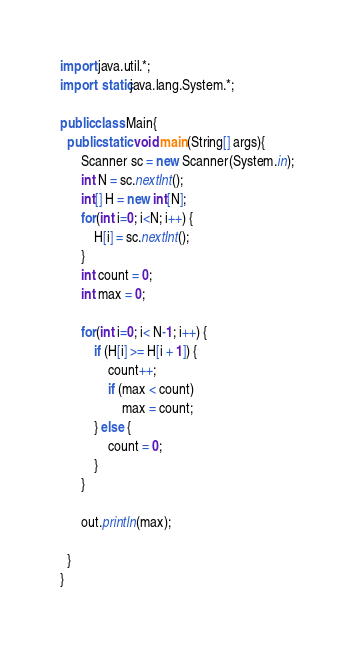Convert code to text. <code><loc_0><loc_0><loc_500><loc_500><_Java_>import java.util.*;
import static java.lang.System.*;

public class Main{
  public static void main(String[] args){
	  Scanner sc = new Scanner(System.in);
	  int N = sc.nextInt();
	  int[] H = new int[N];
	  for(int i=0; i<N; i++) {
		  H[i] = sc.nextInt();
	  }
	  int count = 0;
	  int max = 0;
	  
	  for(int i=0; i< N-1; i++) {
		  if (H[i] >= H[i + 1]) {
			  count++;
			  if (max < count)
				  max = count;
		  } else {
			  count = 0;
		  }
	  }
	  
	  out.println(max);
	  
  }
}</code> 